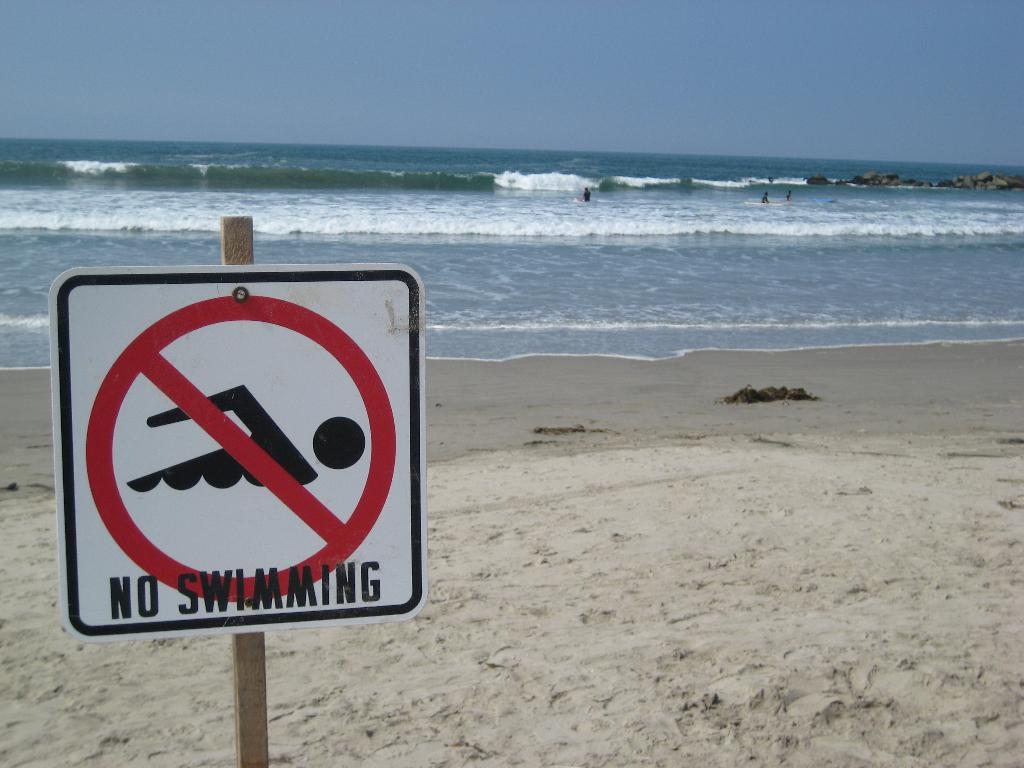What does this sign prohibit?
Give a very brief answer. Swimming. 